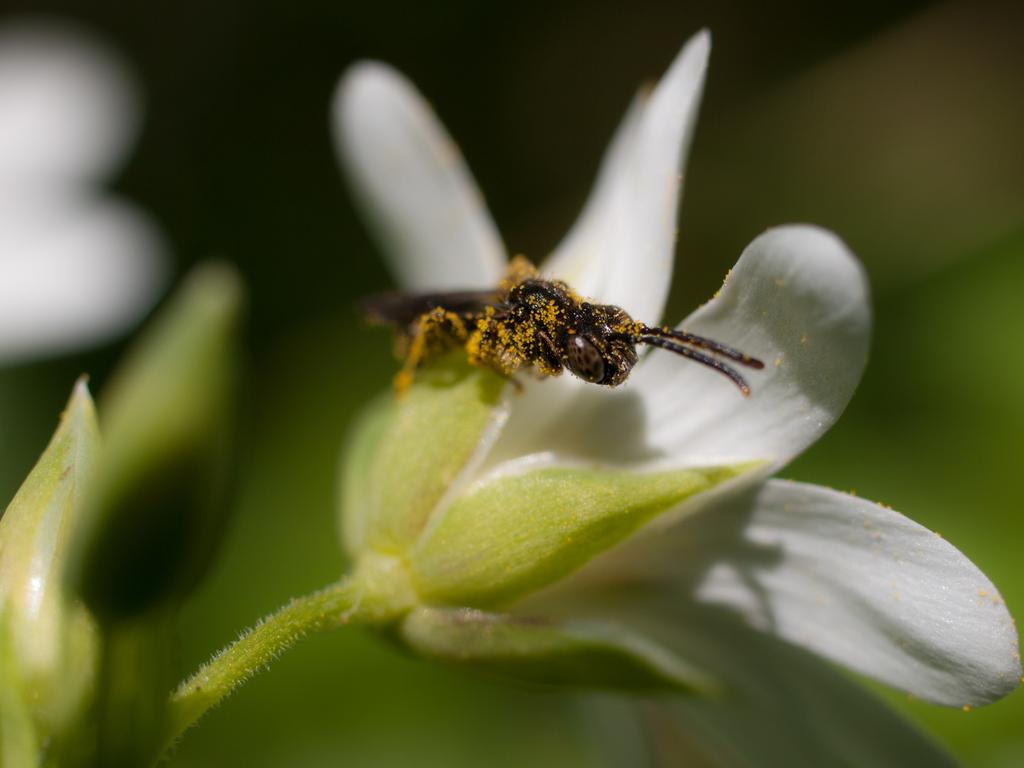What is on the flower in the image? There is an insect on a flower in the image. What can be seen on the left side of the image? There are buds on the left side of the image. How would you describe the background of the image? The background of the image is blurred. What else can be seen in the background of the image? Objects are visible in the background of the image. What type of wool is being used to create the insect's legs in the image? There is no wool or legs present in the image; it features an insect on a flower with no visible legs. 